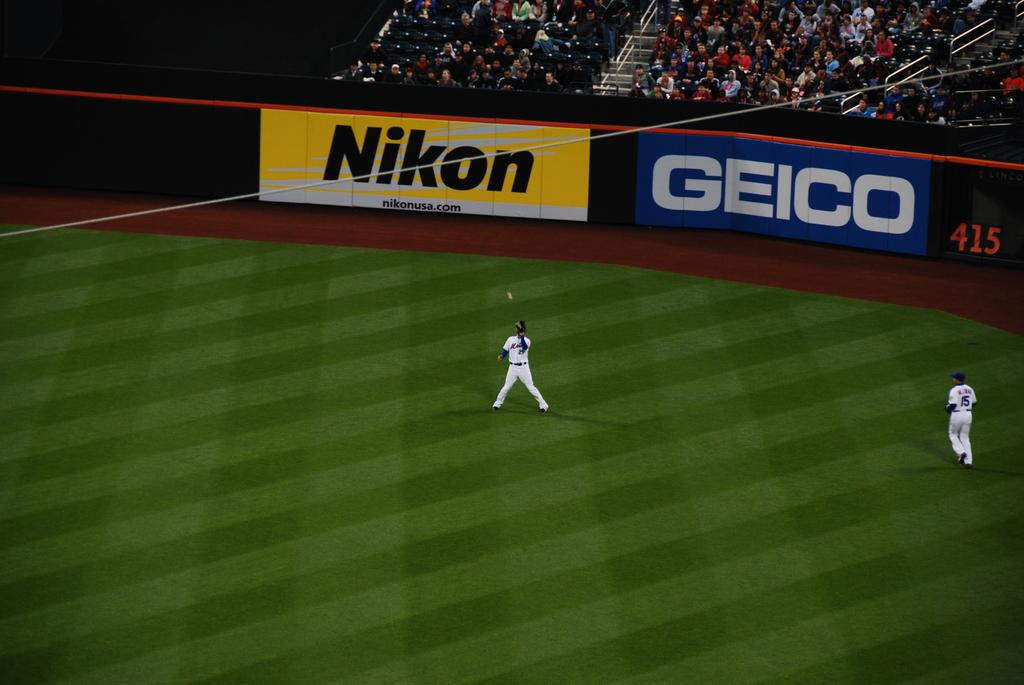Is geico advertising here?
Your answer should be compact. Yes. 